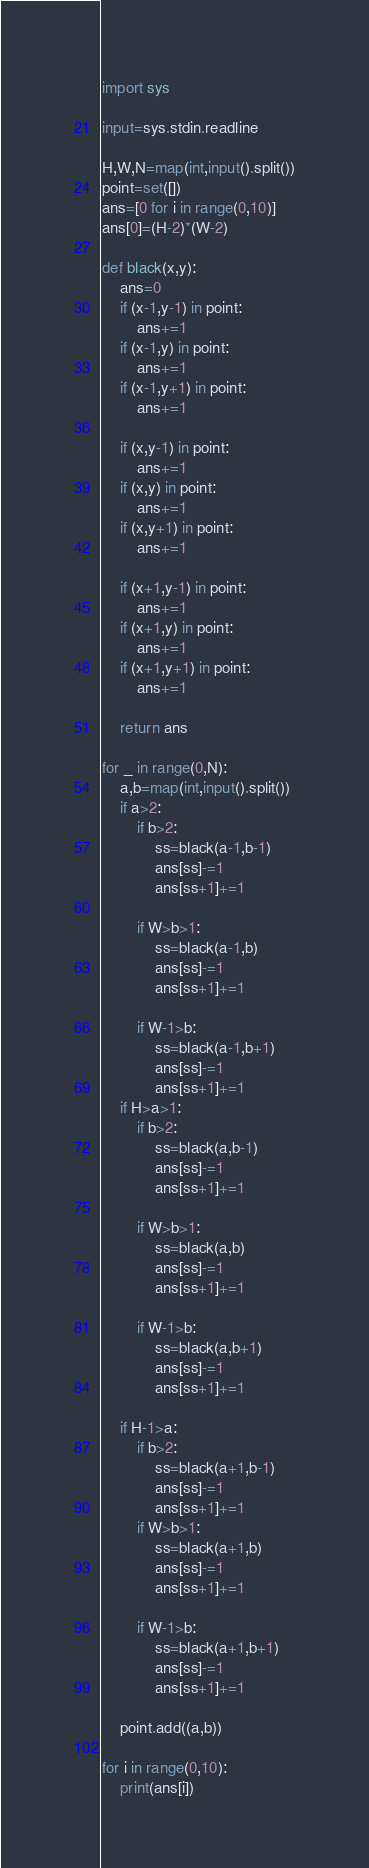Convert code to text. <code><loc_0><loc_0><loc_500><loc_500><_Python_>import sys

input=sys.stdin.readline

H,W,N=map(int,input().split())
point=set([])
ans=[0 for i in range(0,10)]
ans[0]=(H-2)*(W-2)

def black(x,y):
    ans=0
    if (x-1,y-1) in point:
        ans+=1
    if (x-1,y) in point:
        ans+=1
    if (x-1,y+1) in point:
        ans+=1

    if (x,y-1) in point:
        ans+=1
    if (x,y) in point:
        ans+=1
    if (x,y+1) in point:
        ans+=1

    if (x+1,y-1) in point:
        ans+=1
    if (x+1,y) in point:
        ans+=1
    if (x+1,y+1) in point:
        ans+=1
        
    return ans

for _ in range(0,N):
    a,b=map(int,input().split())
    if a>2:
        if b>2:
            ss=black(a-1,b-1)
            ans[ss]-=1
            ans[ss+1]+=1

        if W>b>1:
            ss=black(a-1,b)
            ans[ss]-=1
            ans[ss+1]+=1

        if W-1>b:
            ss=black(a-1,b+1)
            ans[ss]-=1
            ans[ss+1]+=1
    if H>a>1:
        if b>2:
            ss=black(a,b-1)
            ans[ss]-=1
            ans[ss+1]+=1

        if W>b>1:
            ss=black(a,b)
            ans[ss]-=1
            ans[ss+1]+=1

        if W-1>b:
            ss=black(a,b+1)
            ans[ss]-=1
            ans[ss+1]+=1

    if H-1>a:
        if b>2:
            ss=black(a+1,b-1)
            ans[ss]-=1
            ans[ss+1]+=1
        if W>b>1:
            ss=black(a+1,b)
            ans[ss]-=1
            ans[ss+1]+=1

        if W-1>b:
            ss=black(a+1,b+1)
            ans[ss]-=1
            ans[ss+1]+=1

    point.add((a,b))

for i in range(0,10):
    print(ans[i])
</code> 